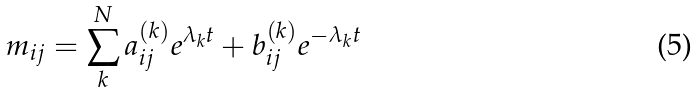Convert formula to latex. <formula><loc_0><loc_0><loc_500><loc_500>m _ { i j } = \sum _ { k } ^ { N } a _ { i j } ^ { ( k ) } e ^ { \lambda _ { k } t } + b _ { i j } ^ { ( k ) } e ^ { - \lambda _ { k } t }</formula> 